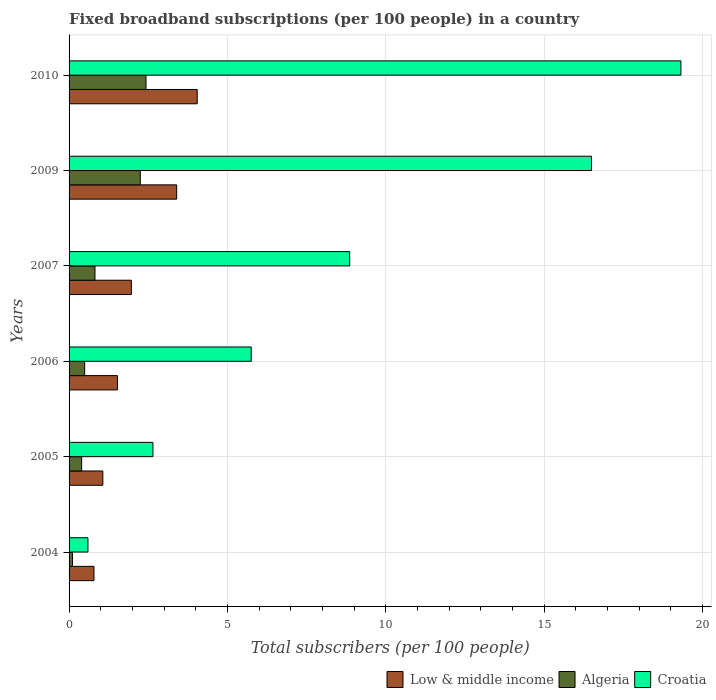How many groups of bars are there?
Keep it short and to the point. 6. How many bars are there on the 5th tick from the top?
Keep it short and to the point. 3. How many bars are there on the 5th tick from the bottom?
Provide a short and direct response. 3. What is the label of the 3rd group of bars from the top?
Make the answer very short. 2007. What is the number of broadband subscriptions in Algeria in 2009?
Provide a succinct answer. 2.25. Across all years, what is the maximum number of broadband subscriptions in Croatia?
Keep it short and to the point. 19.31. Across all years, what is the minimum number of broadband subscriptions in Low & middle income?
Ensure brevity in your answer.  0.79. In which year was the number of broadband subscriptions in Algeria maximum?
Your answer should be very brief. 2010. What is the total number of broadband subscriptions in Algeria in the graph?
Your answer should be compact. 6.49. What is the difference between the number of broadband subscriptions in Algeria in 2005 and that in 2007?
Ensure brevity in your answer.  -0.42. What is the difference between the number of broadband subscriptions in Croatia in 2010 and the number of broadband subscriptions in Low & middle income in 2009?
Keep it short and to the point. 15.92. What is the average number of broadband subscriptions in Croatia per year?
Your response must be concise. 8.94. In the year 2006, what is the difference between the number of broadband subscriptions in Croatia and number of broadband subscriptions in Algeria?
Ensure brevity in your answer.  5.26. In how many years, is the number of broadband subscriptions in Algeria greater than 7 ?
Your answer should be very brief. 0. What is the ratio of the number of broadband subscriptions in Low & middle income in 2006 to that in 2007?
Provide a succinct answer. 0.78. What is the difference between the highest and the second highest number of broadband subscriptions in Algeria?
Provide a succinct answer. 0.18. What is the difference between the highest and the lowest number of broadband subscriptions in Algeria?
Offer a terse response. 2.32. Is the sum of the number of broadband subscriptions in Croatia in 2006 and 2007 greater than the maximum number of broadband subscriptions in Low & middle income across all years?
Your response must be concise. Yes. What does the 3rd bar from the top in 2005 represents?
Provide a succinct answer. Low & middle income. What does the 3rd bar from the bottom in 2010 represents?
Give a very brief answer. Croatia. What is the difference between two consecutive major ticks on the X-axis?
Ensure brevity in your answer.  5. Does the graph contain any zero values?
Give a very brief answer. No. Does the graph contain grids?
Your answer should be very brief. Yes. What is the title of the graph?
Ensure brevity in your answer.  Fixed broadband subscriptions (per 100 people) in a country. What is the label or title of the X-axis?
Offer a terse response. Total subscribers (per 100 people). What is the Total subscribers (per 100 people) of Low & middle income in 2004?
Provide a short and direct response. 0.79. What is the Total subscribers (per 100 people) in Algeria in 2004?
Ensure brevity in your answer.  0.11. What is the Total subscribers (per 100 people) of Croatia in 2004?
Your answer should be compact. 0.6. What is the Total subscribers (per 100 people) in Low & middle income in 2005?
Your answer should be very brief. 1.07. What is the Total subscribers (per 100 people) of Algeria in 2005?
Ensure brevity in your answer.  0.4. What is the Total subscribers (per 100 people) in Croatia in 2005?
Keep it short and to the point. 2.65. What is the Total subscribers (per 100 people) of Low & middle income in 2006?
Provide a short and direct response. 1.53. What is the Total subscribers (per 100 people) of Algeria in 2006?
Provide a succinct answer. 0.49. What is the Total subscribers (per 100 people) of Croatia in 2006?
Your answer should be very brief. 5.75. What is the Total subscribers (per 100 people) of Low & middle income in 2007?
Provide a short and direct response. 1.97. What is the Total subscribers (per 100 people) in Algeria in 2007?
Provide a succinct answer. 0.82. What is the Total subscribers (per 100 people) in Croatia in 2007?
Keep it short and to the point. 8.86. What is the Total subscribers (per 100 people) in Low & middle income in 2009?
Your answer should be very brief. 3.4. What is the Total subscribers (per 100 people) in Algeria in 2009?
Provide a succinct answer. 2.25. What is the Total subscribers (per 100 people) of Croatia in 2009?
Offer a terse response. 16.49. What is the Total subscribers (per 100 people) of Low & middle income in 2010?
Your answer should be very brief. 4.05. What is the Total subscribers (per 100 people) of Algeria in 2010?
Your answer should be compact. 2.43. What is the Total subscribers (per 100 people) in Croatia in 2010?
Your response must be concise. 19.31. Across all years, what is the maximum Total subscribers (per 100 people) of Low & middle income?
Offer a terse response. 4.05. Across all years, what is the maximum Total subscribers (per 100 people) in Algeria?
Your answer should be very brief. 2.43. Across all years, what is the maximum Total subscribers (per 100 people) of Croatia?
Give a very brief answer. 19.31. Across all years, what is the minimum Total subscribers (per 100 people) of Low & middle income?
Offer a very short reply. 0.79. Across all years, what is the minimum Total subscribers (per 100 people) of Algeria?
Ensure brevity in your answer.  0.11. Across all years, what is the minimum Total subscribers (per 100 people) in Croatia?
Provide a short and direct response. 0.6. What is the total Total subscribers (per 100 people) of Low & middle income in the graph?
Offer a terse response. 12.79. What is the total Total subscribers (per 100 people) in Algeria in the graph?
Your answer should be very brief. 6.49. What is the total Total subscribers (per 100 people) in Croatia in the graph?
Your answer should be very brief. 53.66. What is the difference between the Total subscribers (per 100 people) of Low & middle income in 2004 and that in 2005?
Ensure brevity in your answer.  -0.28. What is the difference between the Total subscribers (per 100 people) in Algeria in 2004 and that in 2005?
Offer a terse response. -0.29. What is the difference between the Total subscribers (per 100 people) in Croatia in 2004 and that in 2005?
Provide a succinct answer. -2.05. What is the difference between the Total subscribers (per 100 people) in Low & middle income in 2004 and that in 2006?
Offer a terse response. -0.74. What is the difference between the Total subscribers (per 100 people) in Algeria in 2004 and that in 2006?
Give a very brief answer. -0.39. What is the difference between the Total subscribers (per 100 people) in Croatia in 2004 and that in 2006?
Offer a very short reply. -5.16. What is the difference between the Total subscribers (per 100 people) in Low & middle income in 2004 and that in 2007?
Your response must be concise. -1.18. What is the difference between the Total subscribers (per 100 people) in Algeria in 2004 and that in 2007?
Your response must be concise. -0.71. What is the difference between the Total subscribers (per 100 people) of Croatia in 2004 and that in 2007?
Your answer should be compact. -8.26. What is the difference between the Total subscribers (per 100 people) of Low & middle income in 2004 and that in 2009?
Make the answer very short. -2.61. What is the difference between the Total subscribers (per 100 people) in Algeria in 2004 and that in 2009?
Offer a very short reply. -2.14. What is the difference between the Total subscribers (per 100 people) of Croatia in 2004 and that in 2009?
Offer a very short reply. -15.9. What is the difference between the Total subscribers (per 100 people) in Low & middle income in 2004 and that in 2010?
Offer a very short reply. -3.26. What is the difference between the Total subscribers (per 100 people) of Algeria in 2004 and that in 2010?
Offer a terse response. -2.32. What is the difference between the Total subscribers (per 100 people) in Croatia in 2004 and that in 2010?
Offer a very short reply. -18.72. What is the difference between the Total subscribers (per 100 people) of Low & middle income in 2005 and that in 2006?
Your response must be concise. -0.46. What is the difference between the Total subscribers (per 100 people) in Algeria in 2005 and that in 2006?
Provide a short and direct response. -0.1. What is the difference between the Total subscribers (per 100 people) in Croatia in 2005 and that in 2006?
Your response must be concise. -3.1. What is the difference between the Total subscribers (per 100 people) in Low & middle income in 2005 and that in 2007?
Your answer should be compact. -0.9. What is the difference between the Total subscribers (per 100 people) in Algeria in 2005 and that in 2007?
Your answer should be compact. -0.42. What is the difference between the Total subscribers (per 100 people) of Croatia in 2005 and that in 2007?
Provide a succinct answer. -6.21. What is the difference between the Total subscribers (per 100 people) in Low & middle income in 2005 and that in 2009?
Ensure brevity in your answer.  -2.33. What is the difference between the Total subscribers (per 100 people) in Algeria in 2005 and that in 2009?
Your answer should be compact. -1.85. What is the difference between the Total subscribers (per 100 people) of Croatia in 2005 and that in 2009?
Provide a succinct answer. -13.84. What is the difference between the Total subscribers (per 100 people) in Low & middle income in 2005 and that in 2010?
Your response must be concise. -2.98. What is the difference between the Total subscribers (per 100 people) in Algeria in 2005 and that in 2010?
Provide a short and direct response. -2.03. What is the difference between the Total subscribers (per 100 people) of Croatia in 2005 and that in 2010?
Provide a succinct answer. -16.67. What is the difference between the Total subscribers (per 100 people) in Low & middle income in 2006 and that in 2007?
Provide a succinct answer. -0.44. What is the difference between the Total subscribers (per 100 people) in Algeria in 2006 and that in 2007?
Ensure brevity in your answer.  -0.33. What is the difference between the Total subscribers (per 100 people) in Croatia in 2006 and that in 2007?
Keep it short and to the point. -3.11. What is the difference between the Total subscribers (per 100 people) in Low & middle income in 2006 and that in 2009?
Keep it short and to the point. -1.87. What is the difference between the Total subscribers (per 100 people) of Algeria in 2006 and that in 2009?
Your answer should be very brief. -1.76. What is the difference between the Total subscribers (per 100 people) in Croatia in 2006 and that in 2009?
Your response must be concise. -10.74. What is the difference between the Total subscribers (per 100 people) of Low & middle income in 2006 and that in 2010?
Provide a succinct answer. -2.52. What is the difference between the Total subscribers (per 100 people) in Algeria in 2006 and that in 2010?
Offer a very short reply. -1.94. What is the difference between the Total subscribers (per 100 people) in Croatia in 2006 and that in 2010?
Give a very brief answer. -13.56. What is the difference between the Total subscribers (per 100 people) in Low & middle income in 2007 and that in 2009?
Your answer should be compact. -1.43. What is the difference between the Total subscribers (per 100 people) of Algeria in 2007 and that in 2009?
Your answer should be compact. -1.43. What is the difference between the Total subscribers (per 100 people) in Croatia in 2007 and that in 2009?
Make the answer very short. -7.63. What is the difference between the Total subscribers (per 100 people) of Low & middle income in 2007 and that in 2010?
Provide a short and direct response. -2.08. What is the difference between the Total subscribers (per 100 people) in Algeria in 2007 and that in 2010?
Give a very brief answer. -1.61. What is the difference between the Total subscribers (per 100 people) of Croatia in 2007 and that in 2010?
Ensure brevity in your answer.  -10.46. What is the difference between the Total subscribers (per 100 people) in Low & middle income in 2009 and that in 2010?
Keep it short and to the point. -0.65. What is the difference between the Total subscribers (per 100 people) of Algeria in 2009 and that in 2010?
Provide a succinct answer. -0.18. What is the difference between the Total subscribers (per 100 people) of Croatia in 2009 and that in 2010?
Your answer should be compact. -2.82. What is the difference between the Total subscribers (per 100 people) in Low & middle income in 2004 and the Total subscribers (per 100 people) in Algeria in 2005?
Make the answer very short. 0.39. What is the difference between the Total subscribers (per 100 people) of Low & middle income in 2004 and the Total subscribers (per 100 people) of Croatia in 2005?
Your answer should be very brief. -1.86. What is the difference between the Total subscribers (per 100 people) in Algeria in 2004 and the Total subscribers (per 100 people) in Croatia in 2005?
Make the answer very short. -2.54. What is the difference between the Total subscribers (per 100 people) of Low & middle income in 2004 and the Total subscribers (per 100 people) of Algeria in 2006?
Ensure brevity in your answer.  0.29. What is the difference between the Total subscribers (per 100 people) of Low & middle income in 2004 and the Total subscribers (per 100 people) of Croatia in 2006?
Your response must be concise. -4.96. What is the difference between the Total subscribers (per 100 people) of Algeria in 2004 and the Total subscribers (per 100 people) of Croatia in 2006?
Offer a very short reply. -5.64. What is the difference between the Total subscribers (per 100 people) in Low & middle income in 2004 and the Total subscribers (per 100 people) in Algeria in 2007?
Ensure brevity in your answer.  -0.03. What is the difference between the Total subscribers (per 100 people) of Low & middle income in 2004 and the Total subscribers (per 100 people) of Croatia in 2007?
Provide a short and direct response. -8.07. What is the difference between the Total subscribers (per 100 people) of Algeria in 2004 and the Total subscribers (per 100 people) of Croatia in 2007?
Offer a terse response. -8.75. What is the difference between the Total subscribers (per 100 people) of Low & middle income in 2004 and the Total subscribers (per 100 people) of Algeria in 2009?
Keep it short and to the point. -1.46. What is the difference between the Total subscribers (per 100 people) in Low & middle income in 2004 and the Total subscribers (per 100 people) in Croatia in 2009?
Your answer should be very brief. -15.71. What is the difference between the Total subscribers (per 100 people) of Algeria in 2004 and the Total subscribers (per 100 people) of Croatia in 2009?
Provide a succinct answer. -16.38. What is the difference between the Total subscribers (per 100 people) of Low & middle income in 2004 and the Total subscribers (per 100 people) of Algeria in 2010?
Offer a terse response. -1.64. What is the difference between the Total subscribers (per 100 people) in Low & middle income in 2004 and the Total subscribers (per 100 people) in Croatia in 2010?
Keep it short and to the point. -18.53. What is the difference between the Total subscribers (per 100 people) of Algeria in 2004 and the Total subscribers (per 100 people) of Croatia in 2010?
Your answer should be compact. -19.21. What is the difference between the Total subscribers (per 100 people) in Low & middle income in 2005 and the Total subscribers (per 100 people) in Algeria in 2006?
Ensure brevity in your answer.  0.57. What is the difference between the Total subscribers (per 100 people) in Low & middle income in 2005 and the Total subscribers (per 100 people) in Croatia in 2006?
Make the answer very short. -4.68. What is the difference between the Total subscribers (per 100 people) in Algeria in 2005 and the Total subscribers (per 100 people) in Croatia in 2006?
Offer a very short reply. -5.35. What is the difference between the Total subscribers (per 100 people) of Low & middle income in 2005 and the Total subscribers (per 100 people) of Algeria in 2007?
Give a very brief answer. 0.25. What is the difference between the Total subscribers (per 100 people) in Low & middle income in 2005 and the Total subscribers (per 100 people) in Croatia in 2007?
Make the answer very short. -7.79. What is the difference between the Total subscribers (per 100 people) of Algeria in 2005 and the Total subscribers (per 100 people) of Croatia in 2007?
Provide a short and direct response. -8.46. What is the difference between the Total subscribers (per 100 people) in Low & middle income in 2005 and the Total subscribers (per 100 people) in Algeria in 2009?
Offer a terse response. -1.18. What is the difference between the Total subscribers (per 100 people) in Low & middle income in 2005 and the Total subscribers (per 100 people) in Croatia in 2009?
Your answer should be very brief. -15.42. What is the difference between the Total subscribers (per 100 people) of Algeria in 2005 and the Total subscribers (per 100 people) of Croatia in 2009?
Offer a terse response. -16.09. What is the difference between the Total subscribers (per 100 people) of Low & middle income in 2005 and the Total subscribers (per 100 people) of Algeria in 2010?
Provide a succinct answer. -1.36. What is the difference between the Total subscribers (per 100 people) in Low & middle income in 2005 and the Total subscribers (per 100 people) in Croatia in 2010?
Offer a terse response. -18.25. What is the difference between the Total subscribers (per 100 people) in Algeria in 2005 and the Total subscribers (per 100 people) in Croatia in 2010?
Ensure brevity in your answer.  -18.92. What is the difference between the Total subscribers (per 100 people) of Low & middle income in 2006 and the Total subscribers (per 100 people) of Algeria in 2007?
Your response must be concise. 0.71. What is the difference between the Total subscribers (per 100 people) of Low & middle income in 2006 and the Total subscribers (per 100 people) of Croatia in 2007?
Provide a short and direct response. -7.33. What is the difference between the Total subscribers (per 100 people) in Algeria in 2006 and the Total subscribers (per 100 people) in Croatia in 2007?
Offer a very short reply. -8.37. What is the difference between the Total subscribers (per 100 people) in Low & middle income in 2006 and the Total subscribers (per 100 people) in Algeria in 2009?
Keep it short and to the point. -0.72. What is the difference between the Total subscribers (per 100 people) in Low & middle income in 2006 and the Total subscribers (per 100 people) in Croatia in 2009?
Your response must be concise. -14.96. What is the difference between the Total subscribers (per 100 people) of Algeria in 2006 and the Total subscribers (per 100 people) of Croatia in 2009?
Your answer should be compact. -16. What is the difference between the Total subscribers (per 100 people) of Low & middle income in 2006 and the Total subscribers (per 100 people) of Algeria in 2010?
Your response must be concise. -0.9. What is the difference between the Total subscribers (per 100 people) in Low & middle income in 2006 and the Total subscribers (per 100 people) in Croatia in 2010?
Your answer should be compact. -17.79. What is the difference between the Total subscribers (per 100 people) in Algeria in 2006 and the Total subscribers (per 100 people) in Croatia in 2010?
Your answer should be compact. -18.82. What is the difference between the Total subscribers (per 100 people) of Low & middle income in 2007 and the Total subscribers (per 100 people) of Algeria in 2009?
Provide a short and direct response. -0.28. What is the difference between the Total subscribers (per 100 people) in Low & middle income in 2007 and the Total subscribers (per 100 people) in Croatia in 2009?
Offer a very short reply. -14.52. What is the difference between the Total subscribers (per 100 people) in Algeria in 2007 and the Total subscribers (per 100 people) in Croatia in 2009?
Your answer should be very brief. -15.67. What is the difference between the Total subscribers (per 100 people) of Low & middle income in 2007 and the Total subscribers (per 100 people) of Algeria in 2010?
Provide a short and direct response. -0.46. What is the difference between the Total subscribers (per 100 people) of Low & middle income in 2007 and the Total subscribers (per 100 people) of Croatia in 2010?
Make the answer very short. -17.35. What is the difference between the Total subscribers (per 100 people) of Algeria in 2007 and the Total subscribers (per 100 people) of Croatia in 2010?
Provide a short and direct response. -18.5. What is the difference between the Total subscribers (per 100 people) of Low & middle income in 2009 and the Total subscribers (per 100 people) of Algeria in 2010?
Your answer should be compact. 0.97. What is the difference between the Total subscribers (per 100 people) of Low & middle income in 2009 and the Total subscribers (per 100 people) of Croatia in 2010?
Ensure brevity in your answer.  -15.92. What is the difference between the Total subscribers (per 100 people) in Algeria in 2009 and the Total subscribers (per 100 people) in Croatia in 2010?
Your answer should be very brief. -17.07. What is the average Total subscribers (per 100 people) in Low & middle income per year?
Give a very brief answer. 2.13. What is the average Total subscribers (per 100 people) of Algeria per year?
Your answer should be compact. 1.08. What is the average Total subscribers (per 100 people) of Croatia per year?
Keep it short and to the point. 8.94. In the year 2004, what is the difference between the Total subscribers (per 100 people) of Low & middle income and Total subscribers (per 100 people) of Algeria?
Offer a terse response. 0.68. In the year 2004, what is the difference between the Total subscribers (per 100 people) of Low & middle income and Total subscribers (per 100 people) of Croatia?
Keep it short and to the point. 0.19. In the year 2004, what is the difference between the Total subscribers (per 100 people) of Algeria and Total subscribers (per 100 people) of Croatia?
Your response must be concise. -0.49. In the year 2005, what is the difference between the Total subscribers (per 100 people) of Low & middle income and Total subscribers (per 100 people) of Algeria?
Make the answer very short. 0.67. In the year 2005, what is the difference between the Total subscribers (per 100 people) in Low & middle income and Total subscribers (per 100 people) in Croatia?
Keep it short and to the point. -1.58. In the year 2005, what is the difference between the Total subscribers (per 100 people) in Algeria and Total subscribers (per 100 people) in Croatia?
Offer a terse response. -2.25. In the year 2006, what is the difference between the Total subscribers (per 100 people) in Low & middle income and Total subscribers (per 100 people) in Algeria?
Offer a very short reply. 1.03. In the year 2006, what is the difference between the Total subscribers (per 100 people) of Low & middle income and Total subscribers (per 100 people) of Croatia?
Your answer should be compact. -4.22. In the year 2006, what is the difference between the Total subscribers (per 100 people) in Algeria and Total subscribers (per 100 people) in Croatia?
Your answer should be very brief. -5.26. In the year 2007, what is the difference between the Total subscribers (per 100 people) in Low & middle income and Total subscribers (per 100 people) in Algeria?
Give a very brief answer. 1.15. In the year 2007, what is the difference between the Total subscribers (per 100 people) of Low & middle income and Total subscribers (per 100 people) of Croatia?
Your response must be concise. -6.89. In the year 2007, what is the difference between the Total subscribers (per 100 people) of Algeria and Total subscribers (per 100 people) of Croatia?
Ensure brevity in your answer.  -8.04. In the year 2009, what is the difference between the Total subscribers (per 100 people) of Low & middle income and Total subscribers (per 100 people) of Algeria?
Provide a short and direct response. 1.15. In the year 2009, what is the difference between the Total subscribers (per 100 people) in Low & middle income and Total subscribers (per 100 people) in Croatia?
Offer a terse response. -13.09. In the year 2009, what is the difference between the Total subscribers (per 100 people) in Algeria and Total subscribers (per 100 people) in Croatia?
Make the answer very short. -14.24. In the year 2010, what is the difference between the Total subscribers (per 100 people) in Low & middle income and Total subscribers (per 100 people) in Algeria?
Offer a very short reply. 1.62. In the year 2010, what is the difference between the Total subscribers (per 100 people) of Low & middle income and Total subscribers (per 100 people) of Croatia?
Offer a terse response. -15.27. In the year 2010, what is the difference between the Total subscribers (per 100 people) of Algeria and Total subscribers (per 100 people) of Croatia?
Keep it short and to the point. -16.89. What is the ratio of the Total subscribers (per 100 people) of Low & middle income in 2004 to that in 2005?
Offer a terse response. 0.74. What is the ratio of the Total subscribers (per 100 people) in Algeria in 2004 to that in 2005?
Offer a very short reply. 0.27. What is the ratio of the Total subscribers (per 100 people) of Croatia in 2004 to that in 2005?
Your response must be concise. 0.22. What is the ratio of the Total subscribers (per 100 people) of Low & middle income in 2004 to that in 2006?
Provide a succinct answer. 0.51. What is the ratio of the Total subscribers (per 100 people) of Algeria in 2004 to that in 2006?
Your answer should be very brief. 0.22. What is the ratio of the Total subscribers (per 100 people) of Croatia in 2004 to that in 2006?
Provide a succinct answer. 0.1. What is the ratio of the Total subscribers (per 100 people) in Low & middle income in 2004 to that in 2007?
Provide a succinct answer. 0.4. What is the ratio of the Total subscribers (per 100 people) of Algeria in 2004 to that in 2007?
Make the answer very short. 0.13. What is the ratio of the Total subscribers (per 100 people) of Croatia in 2004 to that in 2007?
Your answer should be very brief. 0.07. What is the ratio of the Total subscribers (per 100 people) of Low & middle income in 2004 to that in 2009?
Offer a terse response. 0.23. What is the ratio of the Total subscribers (per 100 people) of Algeria in 2004 to that in 2009?
Your answer should be very brief. 0.05. What is the ratio of the Total subscribers (per 100 people) of Croatia in 2004 to that in 2009?
Your answer should be compact. 0.04. What is the ratio of the Total subscribers (per 100 people) of Low & middle income in 2004 to that in 2010?
Provide a short and direct response. 0.19. What is the ratio of the Total subscribers (per 100 people) in Algeria in 2004 to that in 2010?
Offer a terse response. 0.04. What is the ratio of the Total subscribers (per 100 people) of Croatia in 2004 to that in 2010?
Make the answer very short. 0.03. What is the ratio of the Total subscribers (per 100 people) in Low & middle income in 2005 to that in 2006?
Offer a very short reply. 0.7. What is the ratio of the Total subscribers (per 100 people) of Algeria in 2005 to that in 2006?
Give a very brief answer. 0.81. What is the ratio of the Total subscribers (per 100 people) in Croatia in 2005 to that in 2006?
Provide a succinct answer. 0.46. What is the ratio of the Total subscribers (per 100 people) in Low & middle income in 2005 to that in 2007?
Offer a very short reply. 0.54. What is the ratio of the Total subscribers (per 100 people) of Algeria in 2005 to that in 2007?
Provide a succinct answer. 0.49. What is the ratio of the Total subscribers (per 100 people) in Croatia in 2005 to that in 2007?
Offer a very short reply. 0.3. What is the ratio of the Total subscribers (per 100 people) in Low & middle income in 2005 to that in 2009?
Keep it short and to the point. 0.31. What is the ratio of the Total subscribers (per 100 people) in Algeria in 2005 to that in 2009?
Keep it short and to the point. 0.18. What is the ratio of the Total subscribers (per 100 people) of Croatia in 2005 to that in 2009?
Provide a succinct answer. 0.16. What is the ratio of the Total subscribers (per 100 people) of Low & middle income in 2005 to that in 2010?
Give a very brief answer. 0.26. What is the ratio of the Total subscribers (per 100 people) in Algeria in 2005 to that in 2010?
Make the answer very short. 0.16. What is the ratio of the Total subscribers (per 100 people) of Croatia in 2005 to that in 2010?
Ensure brevity in your answer.  0.14. What is the ratio of the Total subscribers (per 100 people) of Low & middle income in 2006 to that in 2007?
Your response must be concise. 0.78. What is the ratio of the Total subscribers (per 100 people) in Algeria in 2006 to that in 2007?
Give a very brief answer. 0.6. What is the ratio of the Total subscribers (per 100 people) of Croatia in 2006 to that in 2007?
Provide a short and direct response. 0.65. What is the ratio of the Total subscribers (per 100 people) of Low & middle income in 2006 to that in 2009?
Your response must be concise. 0.45. What is the ratio of the Total subscribers (per 100 people) of Algeria in 2006 to that in 2009?
Your answer should be very brief. 0.22. What is the ratio of the Total subscribers (per 100 people) in Croatia in 2006 to that in 2009?
Ensure brevity in your answer.  0.35. What is the ratio of the Total subscribers (per 100 people) in Low & middle income in 2006 to that in 2010?
Keep it short and to the point. 0.38. What is the ratio of the Total subscribers (per 100 people) of Algeria in 2006 to that in 2010?
Make the answer very short. 0.2. What is the ratio of the Total subscribers (per 100 people) in Croatia in 2006 to that in 2010?
Make the answer very short. 0.3. What is the ratio of the Total subscribers (per 100 people) in Low & middle income in 2007 to that in 2009?
Provide a succinct answer. 0.58. What is the ratio of the Total subscribers (per 100 people) of Algeria in 2007 to that in 2009?
Provide a succinct answer. 0.36. What is the ratio of the Total subscribers (per 100 people) of Croatia in 2007 to that in 2009?
Your response must be concise. 0.54. What is the ratio of the Total subscribers (per 100 people) in Low & middle income in 2007 to that in 2010?
Your response must be concise. 0.49. What is the ratio of the Total subscribers (per 100 people) of Algeria in 2007 to that in 2010?
Make the answer very short. 0.34. What is the ratio of the Total subscribers (per 100 people) in Croatia in 2007 to that in 2010?
Give a very brief answer. 0.46. What is the ratio of the Total subscribers (per 100 people) in Low & middle income in 2009 to that in 2010?
Your answer should be very brief. 0.84. What is the ratio of the Total subscribers (per 100 people) in Algeria in 2009 to that in 2010?
Ensure brevity in your answer.  0.93. What is the ratio of the Total subscribers (per 100 people) in Croatia in 2009 to that in 2010?
Your response must be concise. 0.85. What is the difference between the highest and the second highest Total subscribers (per 100 people) in Low & middle income?
Make the answer very short. 0.65. What is the difference between the highest and the second highest Total subscribers (per 100 people) of Algeria?
Keep it short and to the point. 0.18. What is the difference between the highest and the second highest Total subscribers (per 100 people) in Croatia?
Your answer should be compact. 2.82. What is the difference between the highest and the lowest Total subscribers (per 100 people) in Low & middle income?
Provide a succinct answer. 3.26. What is the difference between the highest and the lowest Total subscribers (per 100 people) in Algeria?
Keep it short and to the point. 2.32. What is the difference between the highest and the lowest Total subscribers (per 100 people) of Croatia?
Provide a short and direct response. 18.72. 